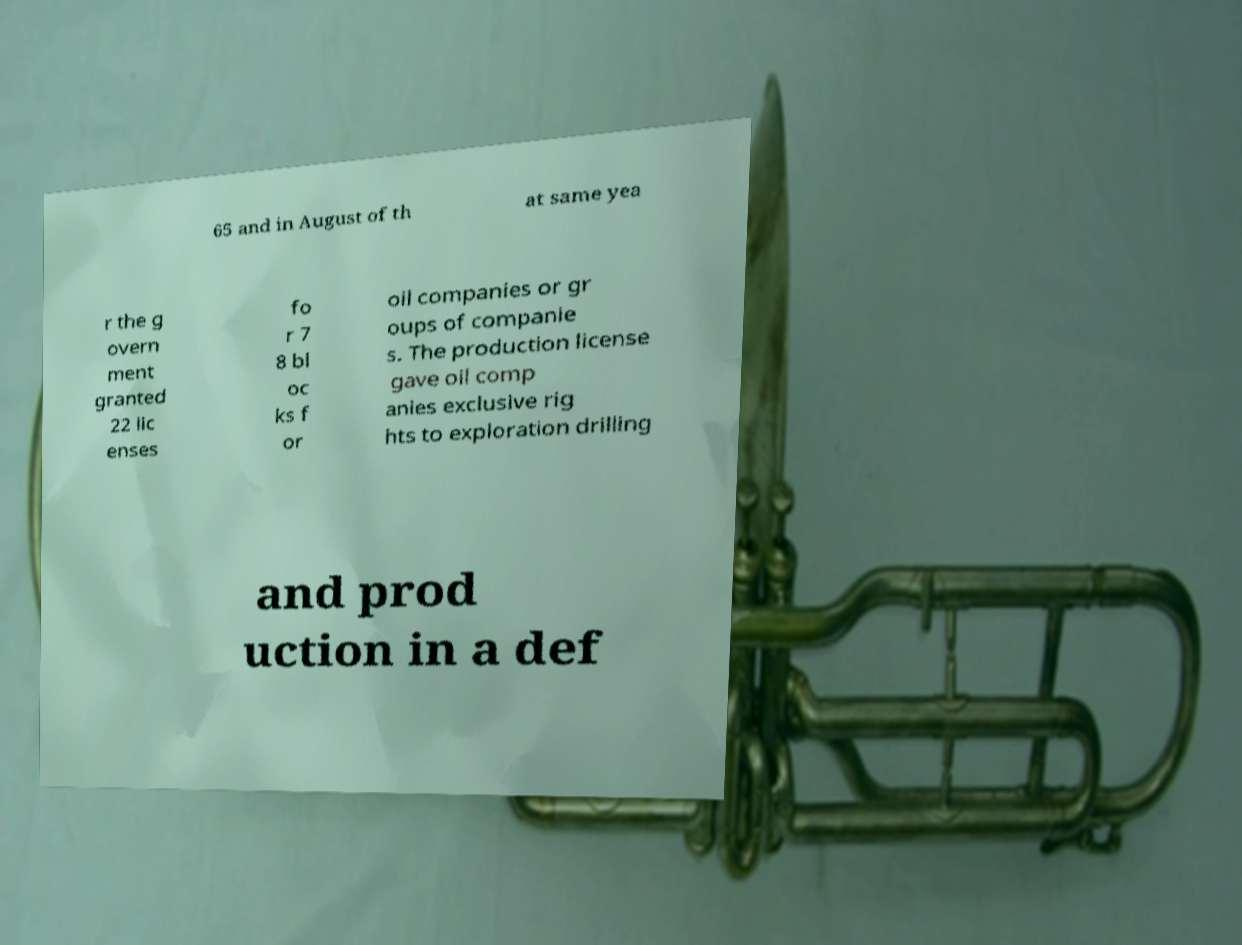Please identify and transcribe the text found in this image. 65 and in August of th at same yea r the g overn ment granted 22 lic enses fo r 7 8 bl oc ks f or oil companies or gr oups of companie s. The production license gave oil comp anies exclusive rig hts to exploration drilling and prod uction in a def 